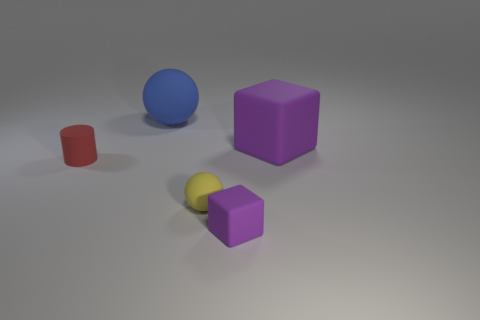What is the shape of the blue matte thing?
Make the answer very short. Sphere. Is the shape of the purple matte thing that is in front of the small red matte cylinder the same as  the yellow thing?
Offer a terse response. No. Is the number of tiny yellow spheres that are to the right of the big blue thing greater than the number of tiny yellow balls left of the small red cylinder?
Provide a succinct answer. Yes. What number of other things are there of the same size as the blue matte thing?
Provide a succinct answer. 1. Does the yellow object have the same shape as the object that is behind the large purple matte object?
Provide a short and direct response. Yes. How many matte objects are either blue objects or small purple cubes?
Your response must be concise. 2. Are there any other blocks that have the same color as the small block?
Provide a succinct answer. Yes. Are any small red rubber blocks visible?
Your answer should be compact. No. Does the blue rubber object have the same shape as the big purple rubber object?
Provide a short and direct response. No. What number of big things are either rubber things or yellow matte balls?
Provide a succinct answer. 2. 